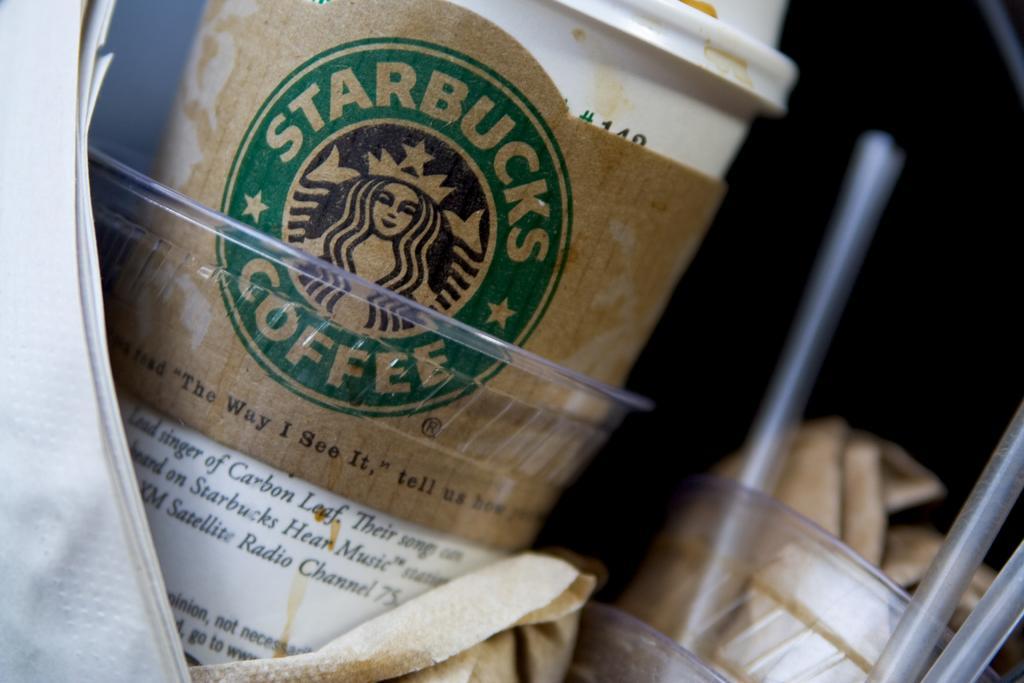Could you give a brief overview of what you see in this image? On the right side, there is an object and a straw in a glass, which is another glass along with two straws. On the right side, there is a white color glass in the other glass, near papers. The background is dark in color. 